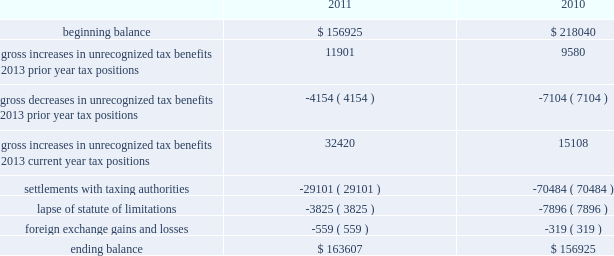A valuation allowance has been established for certain deferred tax assets related to the impairment of investments .
Accounting for uncertainty in income taxes during fiscal 2011 and 2010 , our aggregate changes in our total gross amount of unrecognized tax benefits are summarized as follows ( in thousands ) : beginning balance gross increases in unrecognized tax benefits 2013 prior year tax positions gross decreases in unrecognized tax benefits 2013 prior year tax positions gross increases in unrecognized tax benefits 2013 current year tax positions settlements with taxing authorities lapse of statute of limitations foreign exchange gains and losses ending balance $ 156925 11901 ( 4154 ) 32420 ( 29101 ) ( 3825 ) $ 163607 $ 218040 ( 7104 ) 15108 ( 70484 ) ( 7896 ) $ 156925 as of december 2 , 2011 , the combined amount of accrued interest and penalties related to tax positions taken on our tax returns and included in non-current income taxes payable was approximately $ 12.3 million .
We file income tax returns in the u.s .
On a federal basis and in many u.s .
State and foreign jurisdictions .
We are subject to the continual examination of our income tax returns by the irs and other domestic and foreign tax authorities .
Our major tax jurisdictions are the u.s. , ireland and california .
For california , ireland and the u.s. , the earliest fiscal years open for examination are 2005 , 2006 and 2008 , respectively .
We regularly assess the likelihood of outcomes resulting from these examinations to determine the adequacy of our provision for income taxes and have reserved for potential adjustments that may result from the current examination .
We believe such estimates to be reasonable ; however , there can be no assurance that the final determination of any of these examinations will not have an adverse effect on our operating results and financial position .
In august 2011 , a canadian income tax examination covering our fiscal years 2005 through 2008 was completed .
Our accrued tax and interest related to these years was approximately $ 35 million and was previously reported in long-term income taxes payable .
We reclassified approximately $ 17 million to short-term income taxes payable and decreased deferred tax assets by approximately $ 18 million in conjunction with the aforementioned resolution .
The $ 17 million balance in short-term income taxes payable is partially secured by a letter of credit and is expected to be paid by the first quarter of fiscal 2012 .
In october 2010 , a u.s .
Income tax examination covering our fiscal years 2005 through 2007 was completed .
Our accrued tax and interest related to these years was $ 59 million and was previously reported in long-term income taxes payable .
We paid $ 20 million in conjunction with the aforementioned resolution .
A net income statement tax benefit in the fourth quarter of fiscal 2010 of $ 39 million resulted .
The timing of the resolution of income tax examinations is highly uncertain as are the amounts and timing of tax payments that are part of any audit settlement process .
These events could cause large fluctuations in the balance sheet classification of current and non-current assets and liabilities .
The company believes that before the end of fiscal 2012 , it is reasonably possible that either certain audits will conclude or statutes of limitations on certain income tax examination periods will expire , or both .
Given the uncertainties described above , we can only determine a range of estimated potential decreases in underlying unrecognized tax benefits ranging from $ 0 to approximately $ 40 million .
These amounts would decrease income tax expense under current gaap related to income taxes .
Note 11 .
Restructuring fiscal 2011 restructuring plan in the fourth quarter of fiscal 2011 , in order to better align our resources around our digital media and digital marketing strategies , we initiated a restructuring plan consisting of reductions of approximately 700 full-time positions worldwide and we recorded restructuring charges of approximately $ 78.6 million related to ongoing termination benefits for the position eliminated .
Table of contents adobe systems incorporated notes to consolidated financial statements ( continued ) .
A valuation allowance has been established for certain deferred tax assets related to the impairment of investments .
Accounting for uncertainty in income taxes during fiscal 2011 and 2010 , our aggregate changes in our total gross amount of unrecognized tax benefits are summarized as follows ( in thousands ) : beginning balance gross increases in unrecognized tax benefits 2013 prior year tax positions gross decreases in unrecognized tax benefits 2013 prior year tax positions gross increases in unrecognized tax benefits 2013 current year tax positions settlements with taxing authorities lapse of statute of limitations foreign exchange gains and losses ending balance $ 156925 11901 ( 4154 ) 32420 ( 29101 ) ( 3825 ) $ 163607 $ 218040 ( 7104 ) 15108 ( 70484 ) ( 7896 ) $ 156925 as of december 2 , 2011 , the combined amount of accrued interest and penalties related to tax positions taken on our tax returns and included in non-current income taxes payable was approximately $ 12.3 million .
We file income tax returns in the u.s .
On a federal basis and in many u.s .
State and foreign jurisdictions .
We are subject to the continual examination of our income tax returns by the irs and other domestic and foreign tax authorities .
Our major tax jurisdictions are the u.s. , ireland and california .
For california , ireland and the u.s. , the earliest fiscal years open for examination are 2005 , 2006 and 2008 , respectively .
We regularly assess the likelihood of outcomes resulting from these examinations to determine the adequacy of our provision for income taxes and have reserved for potential adjustments that may result from the current examination .
We believe such estimates to be reasonable ; however , there can be no assurance that the final determination of any of these examinations will not have an adverse effect on our operating results and financial position .
In august 2011 , a canadian income tax examination covering our fiscal years 2005 through 2008 was completed .
Our accrued tax and interest related to these years was approximately $ 35 million and was previously reported in long-term income taxes payable .
We reclassified approximately $ 17 million to short-term income taxes payable and decreased deferred tax assets by approximately $ 18 million in conjunction with the aforementioned resolution .
The $ 17 million balance in short-term income taxes payable is partially secured by a letter of credit and is expected to be paid by the first quarter of fiscal 2012 .
In october 2010 , a u.s .
Income tax examination covering our fiscal years 2005 through 2007 was completed .
Our accrued tax and interest related to these years was $ 59 million and was previously reported in long-term income taxes payable .
We paid $ 20 million in conjunction with the aforementioned resolution .
A net income statement tax benefit in the fourth quarter of fiscal 2010 of $ 39 million resulted .
The timing of the resolution of income tax examinations is highly uncertain as are the amounts and timing of tax payments that are part of any audit settlement process .
These events could cause large fluctuations in the balance sheet classification of current and non-current assets and liabilities .
The company believes that before the end of fiscal 2012 , it is reasonably possible that either certain audits will conclude or statutes of limitations on certain income tax examination periods will expire , or both .
Given the uncertainties described above , we can only determine a range of estimated potential decreases in underlying unrecognized tax benefits ranging from $ 0 to approximately $ 40 million .
These amounts would decrease income tax expense under current gaap related to income taxes .
Note 11 .
Restructuring fiscal 2011 restructuring plan in the fourth quarter of fiscal 2011 , in order to better align our resources around our digital media and digital marketing strategies , we initiated a restructuring plan consisting of reductions of approximately 700 full-time positions worldwide and we recorded restructuring charges of approximately $ 78.6 million related to ongoing termination benefits for the position eliminated .
Table of contents adobe systems incorporated notes to consolidated financial statements ( continued ) .
What was the average ending balance of allowance for unrecognized tax positions? 
Computations: table_average(ending balance, none)
Answer: 160266.0. 